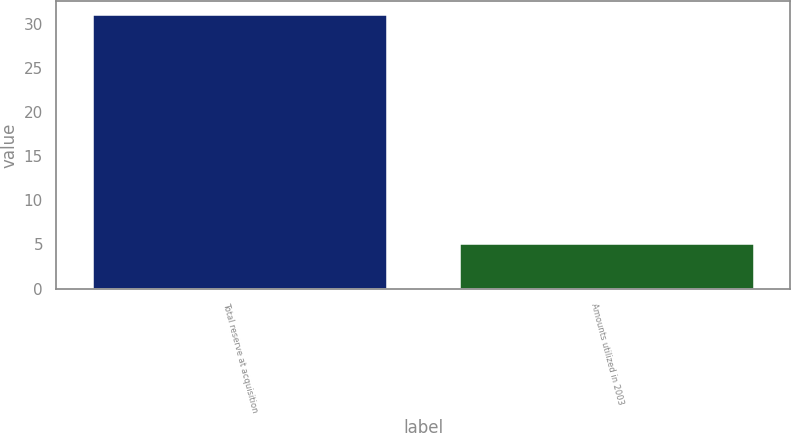Convert chart to OTSL. <chart><loc_0><loc_0><loc_500><loc_500><bar_chart><fcel>Total reserve at acquisition<fcel>Amounts utilized in 2003<nl><fcel>31<fcel>5<nl></chart> 